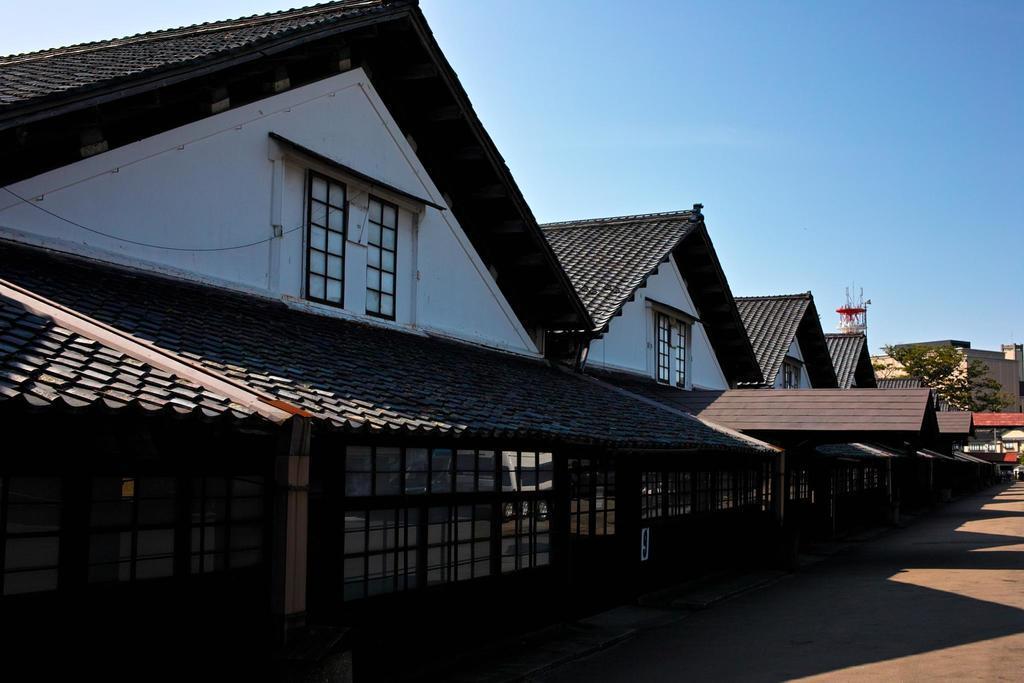Could you give a brief overview of what you see in this image? This image is clicked on the road. Beside the road there are buildings. There are windows to the walls of the buildings. To the right there is a tree behind a building. At the top there is the sky. 